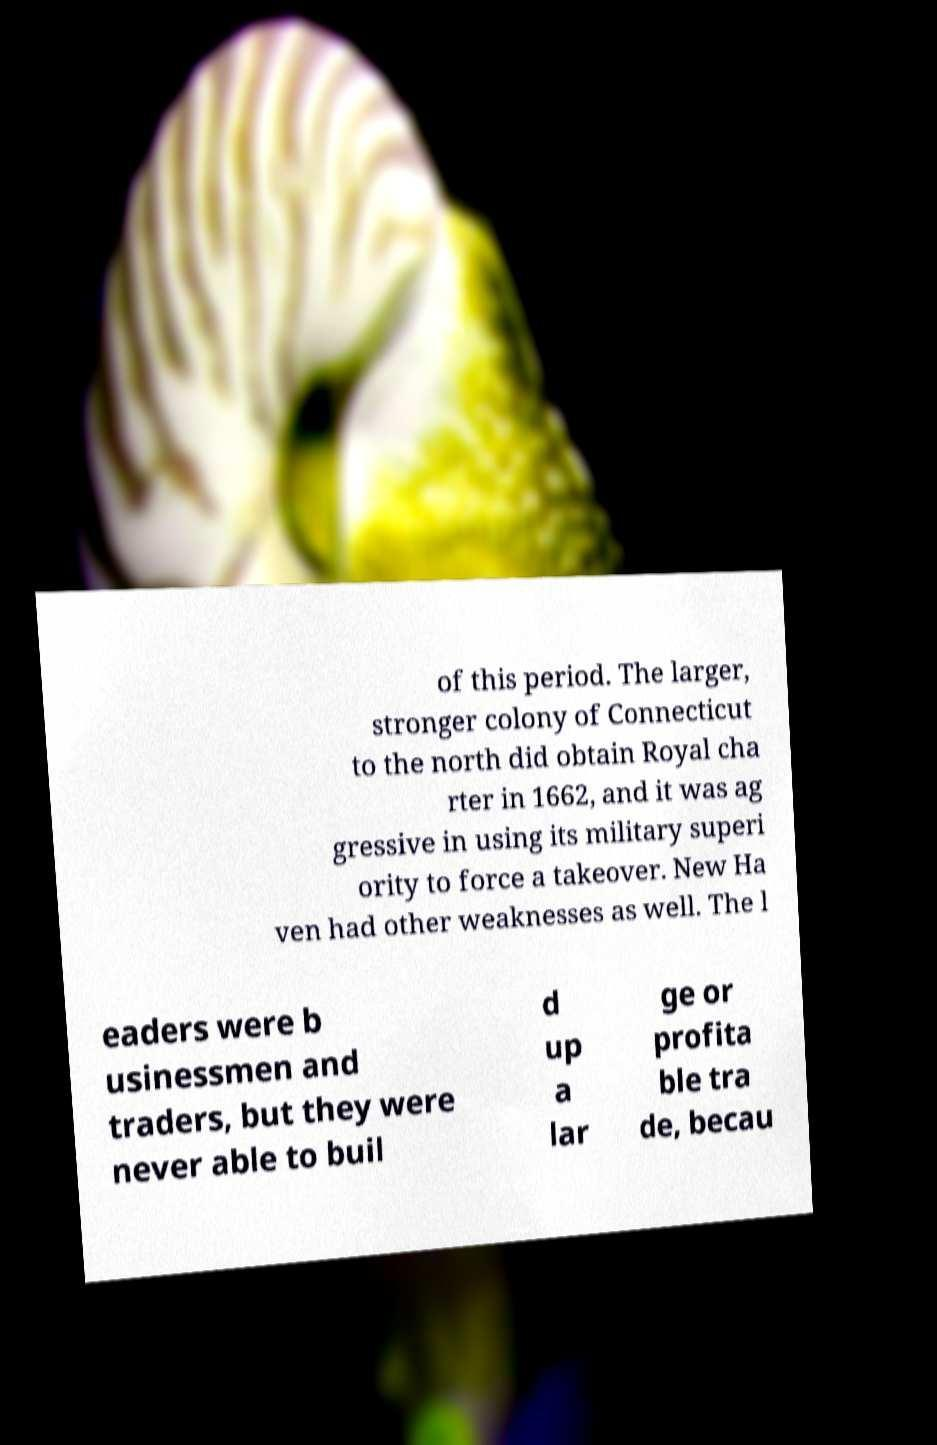I need the written content from this picture converted into text. Can you do that? of this period. The larger, stronger colony of Connecticut to the north did obtain Royal cha rter in 1662, and it was ag gressive in using its military superi ority to force a takeover. New Ha ven had other weaknesses as well. The l eaders were b usinessmen and traders, but they were never able to buil d up a lar ge or profita ble tra de, becau 